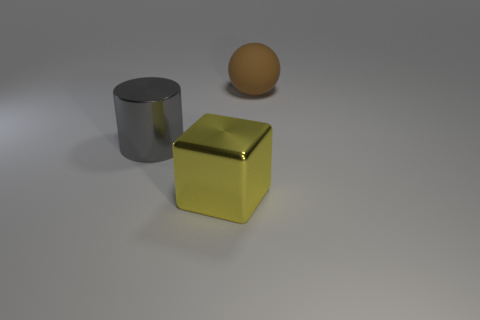Is there anything else that is the same material as the large ball?
Ensure brevity in your answer.  No. There is a big object in front of the big gray metallic thing; what is its color?
Provide a succinct answer. Yellow. Are there an equal number of blocks in front of the rubber object and cyan rubber cubes?
Provide a short and direct response. No. What number of other objects are there of the same shape as the big gray thing?
Ensure brevity in your answer.  0. There is a big gray shiny cylinder; how many gray metallic cylinders are behind it?
Provide a succinct answer. 0. How big is the thing that is in front of the ball and behind the large shiny cube?
Your answer should be very brief. Large. Are there any yellow blocks?
Offer a terse response. Yes. Is the color of the thing that is on the left side of the yellow shiny thing the same as the object in front of the large cylinder?
Provide a short and direct response. No. Do the big object that is in front of the big gray metallic cylinder and the big object that is behind the cylinder have the same material?
Provide a succinct answer. No. How many metallic objects are spheres or big yellow objects?
Your answer should be compact. 1. 